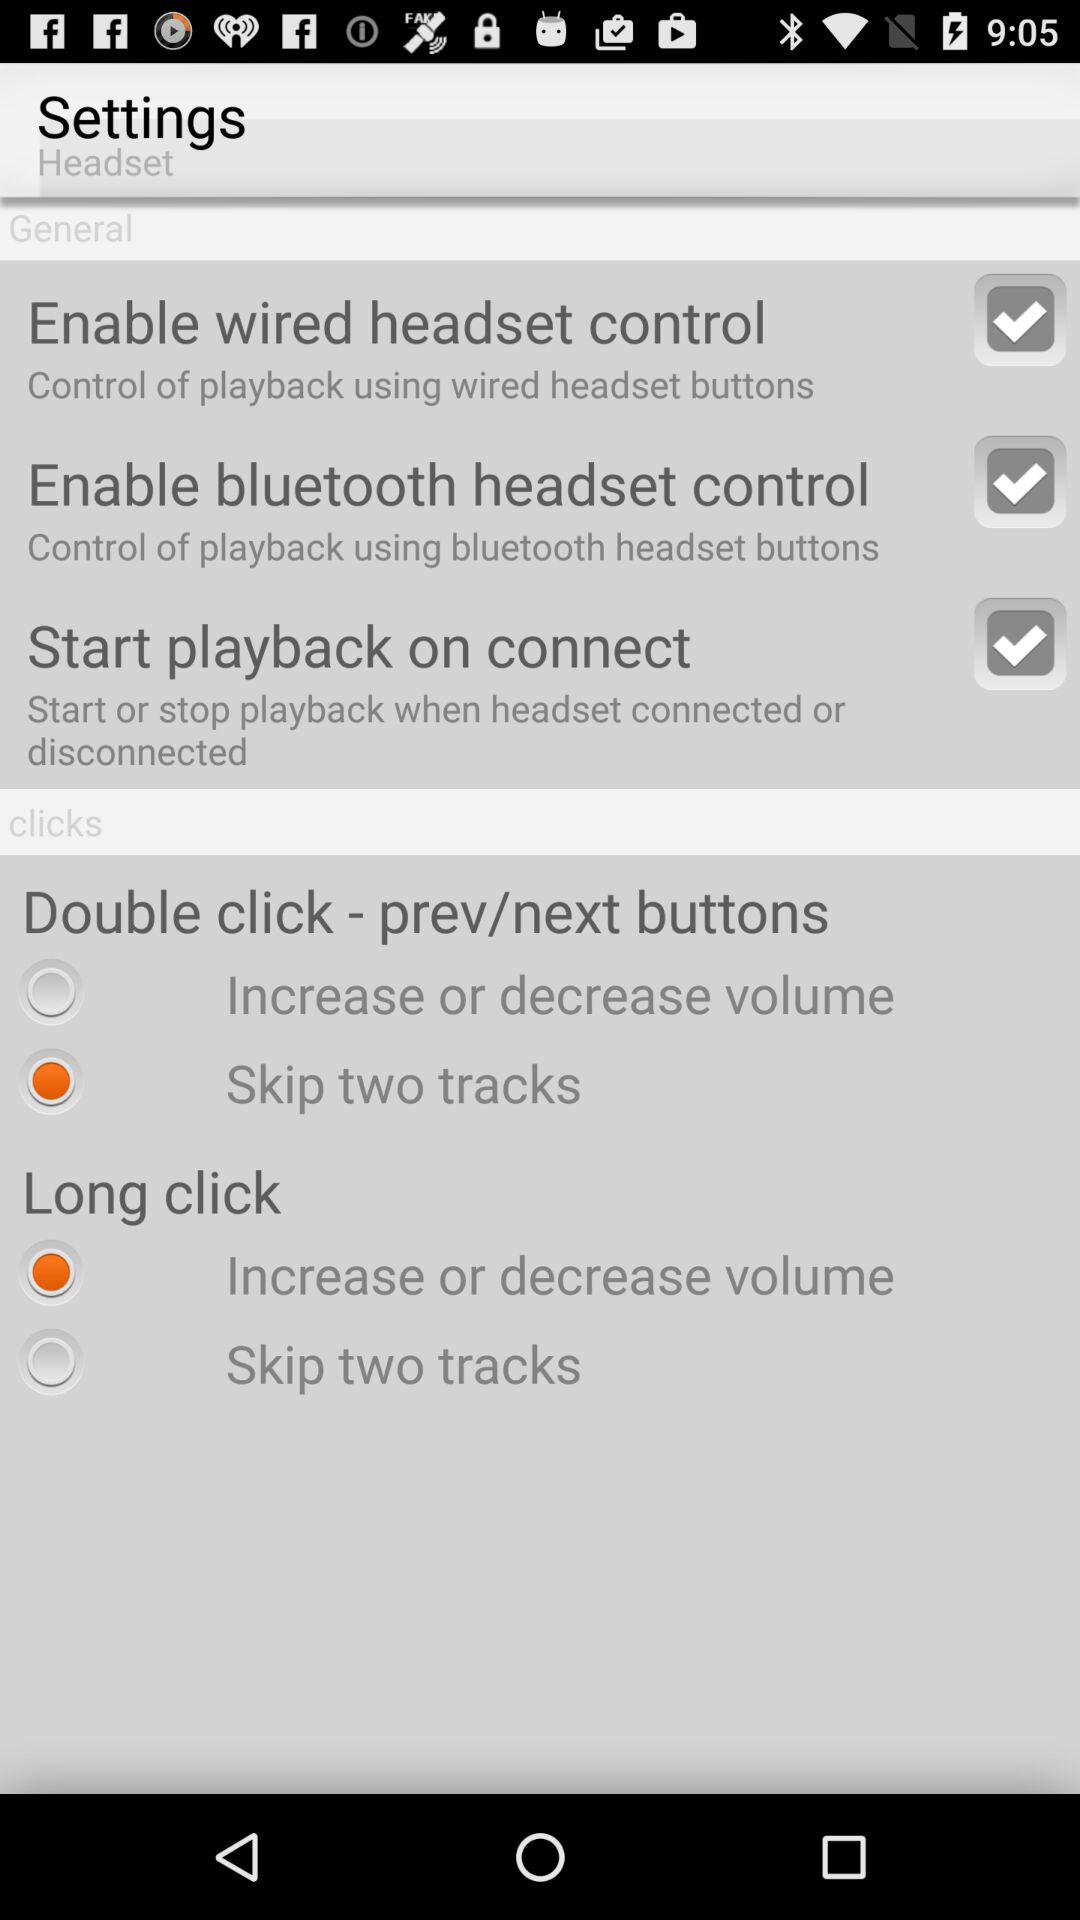Which option has been selected for the long click? The option that has been selected for the long click is "Increase or decrease volume". 